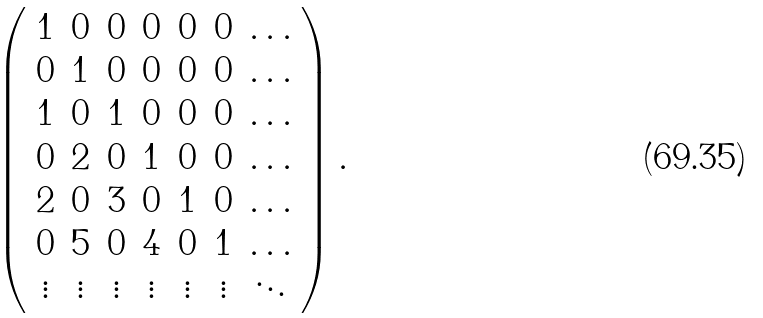Convert formula to latex. <formula><loc_0><loc_0><loc_500><loc_500>\left ( \begin{array} { c c c c c c c } 1 & 0 & 0 & 0 & 0 & 0 & \dots \\ 0 & 1 & 0 & 0 & 0 & 0 & \dots \\ 1 & 0 & 1 & 0 & 0 & 0 & \dots \\ 0 & 2 & 0 & 1 & 0 & 0 & \dots \\ 2 & 0 & 3 & 0 & 1 & 0 & \dots \\ 0 & 5 & 0 & 4 & 0 & 1 & \dots \\ \vdots & \vdots & \vdots & \vdots & \vdots & \vdots & \ddots \end{array} \right ) .</formula> 